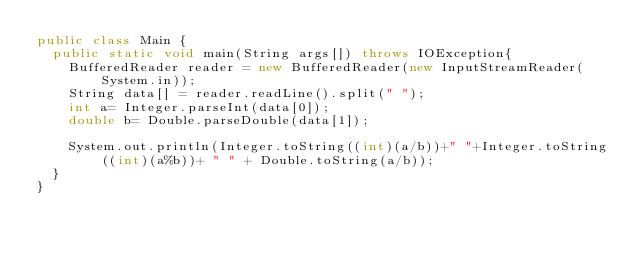<code> <loc_0><loc_0><loc_500><loc_500><_Java_>public class Main {
	public static void main(String args[]) throws IOException{
		BufferedReader reader = new BufferedReader(new InputStreamReader(System.in));
		String data[] = reader.readLine().split(" ");
		int a= Integer.parseInt(data[0]);
		double b= Double.parseDouble(data[1]);
			
		System.out.println(Integer.toString((int)(a/b))+" "+Integer.toString((int)(a%b))+ " " + Double.toString(a/b));
	}
}</code> 